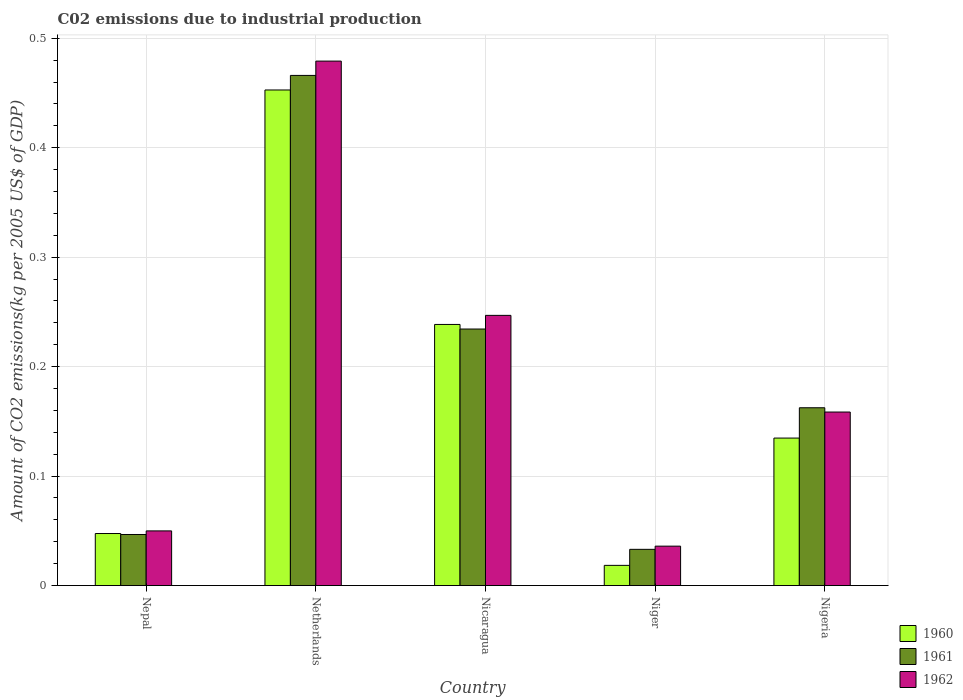How many groups of bars are there?
Make the answer very short. 5. What is the label of the 3rd group of bars from the left?
Provide a succinct answer. Nicaragua. In how many cases, is the number of bars for a given country not equal to the number of legend labels?
Offer a terse response. 0. What is the amount of CO2 emitted due to industrial production in 1960 in Nigeria?
Your answer should be compact. 0.13. Across all countries, what is the maximum amount of CO2 emitted due to industrial production in 1960?
Ensure brevity in your answer.  0.45. Across all countries, what is the minimum amount of CO2 emitted due to industrial production in 1960?
Ensure brevity in your answer.  0.02. In which country was the amount of CO2 emitted due to industrial production in 1962 maximum?
Ensure brevity in your answer.  Netherlands. In which country was the amount of CO2 emitted due to industrial production in 1960 minimum?
Offer a terse response. Niger. What is the total amount of CO2 emitted due to industrial production in 1961 in the graph?
Your answer should be compact. 0.94. What is the difference between the amount of CO2 emitted due to industrial production in 1961 in Netherlands and that in Nicaragua?
Ensure brevity in your answer.  0.23. What is the difference between the amount of CO2 emitted due to industrial production in 1961 in Netherlands and the amount of CO2 emitted due to industrial production in 1962 in Nicaragua?
Make the answer very short. 0.22. What is the average amount of CO2 emitted due to industrial production in 1960 per country?
Provide a succinct answer. 0.18. What is the difference between the amount of CO2 emitted due to industrial production of/in 1960 and amount of CO2 emitted due to industrial production of/in 1961 in Niger?
Keep it short and to the point. -0.01. In how many countries, is the amount of CO2 emitted due to industrial production in 1962 greater than 0.04 kg?
Provide a succinct answer. 4. What is the ratio of the amount of CO2 emitted due to industrial production in 1961 in Nicaragua to that in Nigeria?
Give a very brief answer. 1.44. Is the difference between the amount of CO2 emitted due to industrial production in 1960 in Nepal and Nicaragua greater than the difference between the amount of CO2 emitted due to industrial production in 1961 in Nepal and Nicaragua?
Give a very brief answer. No. What is the difference between the highest and the second highest amount of CO2 emitted due to industrial production in 1961?
Your answer should be compact. 0.3. What is the difference between the highest and the lowest amount of CO2 emitted due to industrial production in 1960?
Ensure brevity in your answer.  0.43. Is the sum of the amount of CO2 emitted due to industrial production in 1962 in Niger and Nigeria greater than the maximum amount of CO2 emitted due to industrial production in 1960 across all countries?
Your answer should be compact. No. What does the 1st bar from the right in Nigeria represents?
Offer a very short reply. 1962. Is it the case that in every country, the sum of the amount of CO2 emitted due to industrial production in 1960 and amount of CO2 emitted due to industrial production in 1962 is greater than the amount of CO2 emitted due to industrial production in 1961?
Your answer should be compact. Yes. How many bars are there?
Offer a terse response. 15. How many countries are there in the graph?
Your response must be concise. 5. How many legend labels are there?
Your response must be concise. 3. How are the legend labels stacked?
Ensure brevity in your answer.  Vertical. What is the title of the graph?
Offer a terse response. C02 emissions due to industrial production. What is the label or title of the Y-axis?
Your response must be concise. Amount of CO2 emissions(kg per 2005 US$ of GDP). What is the Amount of CO2 emissions(kg per 2005 US$ of GDP) in 1960 in Nepal?
Keep it short and to the point. 0.05. What is the Amount of CO2 emissions(kg per 2005 US$ of GDP) of 1961 in Nepal?
Provide a short and direct response. 0.05. What is the Amount of CO2 emissions(kg per 2005 US$ of GDP) of 1962 in Nepal?
Your response must be concise. 0.05. What is the Amount of CO2 emissions(kg per 2005 US$ of GDP) in 1960 in Netherlands?
Offer a terse response. 0.45. What is the Amount of CO2 emissions(kg per 2005 US$ of GDP) in 1961 in Netherlands?
Your answer should be very brief. 0.47. What is the Amount of CO2 emissions(kg per 2005 US$ of GDP) in 1962 in Netherlands?
Ensure brevity in your answer.  0.48. What is the Amount of CO2 emissions(kg per 2005 US$ of GDP) in 1960 in Nicaragua?
Provide a succinct answer. 0.24. What is the Amount of CO2 emissions(kg per 2005 US$ of GDP) of 1961 in Nicaragua?
Your answer should be compact. 0.23. What is the Amount of CO2 emissions(kg per 2005 US$ of GDP) of 1962 in Nicaragua?
Provide a succinct answer. 0.25. What is the Amount of CO2 emissions(kg per 2005 US$ of GDP) in 1960 in Niger?
Provide a succinct answer. 0.02. What is the Amount of CO2 emissions(kg per 2005 US$ of GDP) of 1961 in Niger?
Provide a succinct answer. 0.03. What is the Amount of CO2 emissions(kg per 2005 US$ of GDP) of 1962 in Niger?
Offer a terse response. 0.04. What is the Amount of CO2 emissions(kg per 2005 US$ of GDP) of 1960 in Nigeria?
Your response must be concise. 0.13. What is the Amount of CO2 emissions(kg per 2005 US$ of GDP) in 1961 in Nigeria?
Provide a succinct answer. 0.16. What is the Amount of CO2 emissions(kg per 2005 US$ of GDP) of 1962 in Nigeria?
Keep it short and to the point. 0.16. Across all countries, what is the maximum Amount of CO2 emissions(kg per 2005 US$ of GDP) in 1960?
Make the answer very short. 0.45. Across all countries, what is the maximum Amount of CO2 emissions(kg per 2005 US$ of GDP) of 1961?
Your answer should be compact. 0.47. Across all countries, what is the maximum Amount of CO2 emissions(kg per 2005 US$ of GDP) in 1962?
Offer a terse response. 0.48. Across all countries, what is the minimum Amount of CO2 emissions(kg per 2005 US$ of GDP) in 1960?
Keep it short and to the point. 0.02. Across all countries, what is the minimum Amount of CO2 emissions(kg per 2005 US$ of GDP) of 1961?
Offer a very short reply. 0.03. Across all countries, what is the minimum Amount of CO2 emissions(kg per 2005 US$ of GDP) in 1962?
Provide a succinct answer. 0.04. What is the total Amount of CO2 emissions(kg per 2005 US$ of GDP) in 1960 in the graph?
Provide a short and direct response. 0.89. What is the total Amount of CO2 emissions(kg per 2005 US$ of GDP) of 1961 in the graph?
Give a very brief answer. 0.94. What is the total Amount of CO2 emissions(kg per 2005 US$ of GDP) of 1962 in the graph?
Your answer should be very brief. 0.97. What is the difference between the Amount of CO2 emissions(kg per 2005 US$ of GDP) in 1960 in Nepal and that in Netherlands?
Provide a succinct answer. -0.41. What is the difference between the Amount of CO2 emissions(kg per 2005 US$ of GDP) of 1961 in Nepal and that in Netherlands?
Give a very brief answer. -0.42. What is the difference between the Amount of CO2 emissions(kg per 2005 US$ of GDP) of 1962 in Nepal and that in Netherlands?
Offer a terse response. -0.43. What is the difference between the Amount of CO2 emissions(kg per 2005 US$ of GDP) of 1960 in Nepal and that in Nicaragua?
Provide a short and direct response. -0.19. What is the difference between the Amount of CO2 emissions(kg per 2005 US$ of GDP) of 1961 in Nepal and that in Nicaragua?
Provide a short and direct response. -0.19. What is the difference between the Amount of CO2 emissions(kg per 2005 US$ of GDP) of 1962 in Nepal and that in Nicaragua?
Offer a very short reply. -0.2. What is the difference between the Amount of CO2 emissions(kg per 2005 US$ of GDP) in 1960 in Nepal and that in Niger?
Make the answer very short. 0.03. What is the difference between the Amount of CO2 emissions(kg per 2005 US$ of GDP) of 1961 in Nepal and that in Niger?
Make the answer very short. 0.01. What is the difference between the Amount of CO2 emissions(kg per 2005 US$ of GDP) in 1962 in Nepal and that in Niger?
Ensure brevity in your answer.  0.01. What is the difference between the Amount of CO2 emissions(kg per 2005 US$ of GDP) in 1960 in Nepal and that in Nigeria?
Offer a very short reply. -0.09. What is the difference between the Amount of CO2 emissions(kg per 2005 US$ of GDP) of 1961 in Nepal and that in Nigeria?
Ensure brevity in your answer.  -0.12. What is the difference between the Amount of CO2 emissions(kg per 2005 US$ of GDP) in 1962 in Nepal and that in Nigeria?
Keep it short and to the point. -0.11. What is the difference between the Amount of CO2 emissions(kg per 2005 US$ of GDP) of 1960 in Netherlands and that in Nicaragua?
Your answer should be compact. 0.21. What is the difference between the Amount of CO2 emissions(kg per 2005 US$ of GDP) in 1961 in Netherlands and that in Nicaragua?
Give a very brief answer. 0.23. What is the difference between the Amount of CO2 emissions(kg per 2005 US$ of GDP) of 1962 in Netherlands and that in Nicaragua?
Ensure brevity in your answer.  0.23. What is the difference between the Amount of CO2 emissions(kg per 2005 US$ of GDP) in 1960 in Netherlands and that in Niger?
Offer a terse response. 0.43. What is the difference between the Amount of CO2 emissions(kg per 2005 US$ of GDP) of 1961 in Netherlands and that in Niger?
Ensure brevity in your answer.  0.43. What is the difference between the Amount of CO2 emissions(kg per 2005 US$ of GDP) of 1962 in Netherlands and that in Niger?
Provide a succinct answer. 0.44. What is the difference between the Amount of CO2 emissions(kg per 2005 US$ of GDP) of 1960 in Netherlands and that in Nigeria?
Provide a short and direct response. 0.32. What is the difference between the Amount of CO2 emissions(kg per 2005 US$ of GDP) of 1961 in Netherlands and that in Nigeria?
Provide a succinct answer. 0.3. What is the difference between the Amount of CO2 emissions(kg per 2005 US$ of GDP) of 1962 in Netherlands and that in Nigeria?
Offer a terse response. 0.32. What is the difference between the Amount of CO2 emissions(kg per 2005 US$ of GDP) in 1960 in Nicaragua and that in Niger?
Keep it short and to the point. 0.22. What is the difference between the Amount of CO2 emissions(kg per 2005 US$ of GDP) in 1961 in Nicaragua and that in Niger?
Provide a succinct answer. 0.2. What is the difference between the Amount of CO2 emissions(kg per 2005 US$ of GDP) in 1962 in Nicaragua and that in Niger?
Keep it short and to the point. 0.21. What is the difference between the Amount of CO2 emissions(kg per 2005 US$ of GDP) of 1960 in Nicaragua and that in Nigeria?
Ensure brevity in your answer.  0.1. What is the difference between the Amount of CO2 emissions(kg per 2005 US$ of GDP) in 1961 in Nicaragua and that in Nigeria?
Your response must be concise. 0.07. What is the difference between the Amount of CO2 emissions(kg per 2005 US$ of GDP) in 1962 in Nicaragua and that in Nigeria?
Provide a short and direct response. 0.09. What is the difference between the Amount of CO2 emissions(kg per 2005 US$ of GDP) of 1960 in Niger and that in Nigeria?
Give a very brief answer. -0.12. What is the difference between the Amount of CO2 emissions(kg per 2005 US$ of GDP) of 1961 in Niger and that in Nigeria?
Ensure brevity in your answer.  -0.13. What is the difference between the Amount of CO2 emissions(kg per 2005 US$ of GDP) in 1962 in Niger and that in Nigeria?
Offer a terse response. -0.12. What is the difference between the Amount of CO2 emissions(kg per 2005 US$ of GDP) in 1960 in Nepal and the Amount of CO2 emissions(kg per 2005 US$ of GDP) in 1961 in Netherlands?
Your response must be concise. -0.42. What is the difference between the Amount of CO2 emissions(kg per 2005 US$ of GDP) in 1960 in Nepal and the Amount of CO2 emissions(kg per 2005 US$ of GDP) in 1962 in Netherlands?
Ensure brevity in your answer.  -0.43. What is the difference between the Amount of CO2 emissions(kg per 2005 US$ of GDP) of 1961 in Nepal and the Amount of CO2 emissions(kg per 2005 US$ of GDP) of 1962 in Netherlands?
Offer a very short reply. -0.43. What is the difference between the Amount of CO2 emissions(kg per 2005 US$ of GDP) in 1960 in Nepal and the Amount of CO2 emissions(kg per 2005 US$ of GDP) in 1961 in Nicaragua?
Ensure brevity in your answer.  -0.19. What is the difference between the Amount of CO2 emissions(kg per 2005 US$ of GDP) in 1960 in Nepal and the Amount of CO2 emissions(kg per 2005 US$ of GDP) in 1962 in Nicaragua?
Provide a succinct answer. -0.2. What is the difference between the Amount of CO2 emissions(kg per 2005 US$ of GDP) of 1961 in Nepal and the Amount of CO2 emissions(kg per 2005 US$ of GDP) of 1962 in Nicaragua?
Ensure brevity in your answer.  -0.2. What is the difference between the Amount of CO2 emissions(kg per 2005 US$ of GDP) of 1960 in Nepal and the Amount of CO2 emissions(kg per 2005 US$ of GDP) of 1961 in Niger?
Your answer should be compact. 0.01. What is the difference between the Amount of CO2 emissions(kg per 2005 US$ of GDP) of 1960 in Nepal and the Amount of CO2 emissions(kg per 2005 US$ of GDP) of 1962 in Niger?
Provide a succinct answer. 0.01. What is the difference between the Amount of CO2 emissions(kg per 2005 US$ of GDP) of 1961 in Nepal and the Amount of CO2 emissions(kg per 2005 US$ of GDP) of 1962 in Niger?
Offer a very short reply. 0.01. What is the difference between the Amount of CO2 emissions(kg per 2005 US$ of GDP) of 1960 in Nepal and the Amount of CO2 emissions(kg per 2005 US$ of GDP) of 1961 in Nigeria?
Offer a terse response. -0.11. What is the difference between the Amount of CO2 emissions(kg per 2005 US$ of GDP) in 1960 in Nepal and the Amount of CO2 emissions(kg per 2005 US$ of GDP) in 1962 in Nigeria?
Your response must be concise. -0.11. What is the difference between the Amount of CO2 emissions(kg per 2005 US$ of GDP) of 1961 in Nepal and the Amount of CO2 emissions(kg per 2005 US$ of GDP) of 1962 in Nigeria?
Your answer should be very brief. -0.11. What is the difference between the Amount of CO2 emissions(kg per 2005 US$ of GDP) of 1960 in Netherlands and the Amount of CO2 emissions(kg per 2005 US$ of GDP) of 1961 in Nicaragua?
Your response must be concise. 0.22. What is the difference between the Amount of CO2 emissions(kg per 2005 US$ of GDP) in 1960 in Netherlands and the Amount of CO2 emissions(kg per 2005 US$ of GDP) in 1962 in Nicaragua?
Ensure brevity in your answer.  0.21. What is the difference between the Amount of CO2 emissions(kg per 2005 US$ of GDP) in 1961 in Netherlands and the Amount of CO2 emissions(kg per 2005 US$ of GDP) in 1962 in Nicaragua?
Provide a succinct answer. 0.22. What is the difference between the Amount of CO2 emissions(kg per 2005 US$ of GDP) of 1960 in Netherlands and the Amount of CO2 emissions(kg per 2005 US$ of GDP) of 1961 in Niger?
Provide a short and direct response. 0.42. What is the difference between the Amount of CO2 emissions(kg per 2005 US$ of GDP) in 1960 in Netherlands and the Amount of CO2 emissions(kg per 2005 US$ of GDP) in 1962 in Niger?
Keep it short and to the point. 0.42. What is the difference between the Amount of CO2 emissions(kg per 2005 US$ of GDP) of 1961 in Netherlands and the Amount of CO2 emissions(kg per 2005 US$ of GDP) of 1962 in Niger?
Make the answer very short. 0.43. What is the difference between the Amount of CO2 emissions(kg per 2005 US$ of GDP) in 1960 in Netherlands and the Amount of CO2 emissions(kg per 2005 US$ of GDP) in 1961 in Nigeria?
Offer a terse response. 0.29. What is the difference between the Amount of CO2 emissions(kg per 2005 US$ of GDP) of 1960 in Netherlands and the Amount of CO2 emissions(kg per 2005 US$ of GDP) of 1962 in Nigeria?
Offer a very short reply. 0.29. What is the difference between the Amount of CO2 emissions(kg per 2005 US$ of GDP) in 1961 in Netherlands and the Amount of CO2 emissions(kg per 2005 US$ of GDP) in 1962 in Nigeria?
Provide a short and direct response. 0.31. What is the difference between the Amount of CO2 emissions(kg per 2005 US$ of GDP) of 1960 in Nicaragua and the Amount of CO2 emissions(kg per 2005 US$ of GDP) of 1961 in Niger?
Give a very brief answer. 0.21. What is the difference between the Amount of CO2 emissions(kg per 2005 US$ of GDP) of 1960 in Nicaragua and the Amount of CO2 emissions(kg per 2005 US$ of GDP) of 1962 in Niger?
Provide a succinct answer. 0.2. What is the difference between the Amount of CO2 emissions(kg per 2005 US$ of GDP) in 1961 in Nicaragua and the Amount of CO2 emissions(kg per 2005 US$ of GDP) in 1962 in Niger?
Offer a very short reply. 0.2. What is the difference between the Amount of CO2 emissions(kg per 2005 US$ of GDP) in 1960 in Nicaragua and the Amount of CO2 emissions(kg per 2005 US$ of GDP) in 1961 in Nigeria?
Make the answer very short. 0.08. What is the difference between the Amount of CO2 emissions(kg per 2005 US$ of GDP) in 1960 in Nicaragua and the Amount of CO2 emissions(kg per 2005 US$ of GDP) in 1962 in Nigeria?
Your answer should be very brief. 0.08. What is the difference between the Amount of CO2 emissions(kg per 2005 US$ of GDP) in 1961 in Nicaragua and the Amount of CO2 emissions(kg per 2005 US$ of GDP) in 1962 in Nigeria?
Provide a succinct answer. 0.08. What is the difference between the Amount of CO2 emissions(kg per 2005 US$ of GDP) in 1960 in Niger and the Amount of CO2 emissions(kg per 2005 US$ of GDP) in 1961 in Nigeria?
Offer a terse response. -0.14. What is the difference between the Amount of CO2 emissions(kg per 2005 US$ of GDP) in 1960 in Niger and the Amount of CO2 emissions(kg per 2005 US$ of GDP) in 1962 in Nigeria?
Make the answer very short. -0.14. What is the difference between the Amount of CO2 emissions(kg per 2005 US$ of GDP) in 1961 in Niger and the Amount of CO2 emissions(kg per 2005 US$ of GDP) in 1962 in Nigeria?
Your answer should be very brief. -0.13. What is the average Amount of CO2 emissions(kg per 2005 US$ of GDP) in 1960 per country?
Offer a very short reply. 0.18. What is the average Amount of CO2 emissions(kg per 2005 US$ of GDP) in 1961 per country?
Ensure brevity in your answer.  0.19. What is the average Amount of CO2 emissions(kg per 2005 US$ of GDP) in 1962 per country?
Ensure brevity in your answer.  0.19. What is the difference between the Amount of CO2 emissions(kg per 2005 US$ of GDP) in 1960 and Amount of CO2 emissions(kg per 2005 US$ of GDP) in 1961 in Nepal?
Your answer should be compact. 0. What is the difference between the Amount of CO2 emissions(kg per 2005 US$ of GDP) of 1960 and Amount of CO2 emissions(kg per 2005 US$ of GDP) of 1962 in Nepal?
Your answer should be compact. -0. What is the difference between the Amount of CO2 emissions(kg per 2005 US$ of GDP) of 1961 and Amount of CO2 emissions(kg per 2005 US$ of GDP) of 1962 in Nepal?
Offer a very short reply. -0. What is the difference between the Amount of CO2 emissions(kg per 2005 US$ of GDP) of 1960 and Amount of CO2 emissions(kg per 2005 US$ of GDP) of 1961 in Netherlands?
Your answer should be compact. -0.01. What is the difference between the Amount of CO2 emissions(kg per 2005 US$ of GDP) of 1960 and Amount of CO2 emissions(kg per 2005 US$ of GDP) of 1962 in Netherlands?
Provide a short and direct response. -0.03. What is the difference between the Amount of CO2 emissions(kg per 2005 US$ of GDP) in 1961 and Amount of CO2 emissions(kg per 2005 US$ of GDP) in 1962 in Netherlands?
Your answer should be very brief. -0.01. What is the difference between the Amount of CO2 emissions(kg per 2005 US$ of GDP) in 1960 and Amount of CO2 emissions(kg per 2005 US$ of GDP) in 1961 in Nicaragua?
Ensure brevity in your answer.  0. What is the difference between the Amount of CO2 emissions(kg per 2005 US$ of GDP) of 1960 and Amount of CO2 emissions(kg per 2005 US$ of GDP) of 1962 in Nicaragua?
Your answer should be compact. -0.01. What is the difference between the Amount of CO2 emissions(kg per 2005 US$ of GDP) of 1961 and Amount of CO2 emissions(kg per 2005 US$ of GDP) of 1962 in Nicaragua?
Offer a terse response. -0.01. What is the difference between the Amount of CO2 emissions(kg per 2005 US$ of GDP) of 1960 and Amount of CO2 emissions(kg per 2005 US$ of GDP) of 1961 in Niger?
Provide a short and direct response. -0.01. What is the difference between the Amount of CO2 emissions(kg per 2005 US$ of GDP) of 1960 and Amount of CO2 emissions(kg per 2005 US$ of GDP) of 1962 in Niger?
Your response must be concise. -0.02. What is the difference between the Amount of CO2 emissions(kg per 2005 US$ of GDP) in 1961 and Amount of CO2 emissions(kg per 2005 US$ of GDP) in 1962 in Niger?
Make the answer very short. -0. What is the difference between the Amount of CO2 emissions(kg per 2005 US$ of GDP) of 1960 and Amount of CO2 emissions(kg per 2005 US$ of GDP) of 1961 in Nigeria?
Make the answer very short. -0.03. What is the difference between the Amount of CO2 emissions(kg per 2005 US$ of GDP) in 1960 and Amount of CO2 emissions(kg per 2005 US$ of GDP) in 1962 in Nigeria?
Your response must be concise. -0.02. What is the difference between the Amount of CO2 emissions(kg per 2005 US$ of GDP) in 1961 and Amount of CO2 emissions(kg per 2005 US$ of GDP) in 1962 in Nigeria?
Make the answer very short. 0. What is the ratio of the Amount of CO2 emissions(kg per 2005 US$ of GDP) in 1960 in Nepal to that in Netherlands?
Provide a short and direct response. 0.1. What is the ratio of the Amount of CO2 emissions(kg per 2005 US$ of GDP) in 1961 in Nepal to that in Netherlands?
Give a very brief answer. 0.1. What is the ratio of the Amount of CO2 emissions(kg per 2005 US$ of GDP) in 1962 in Nepal to that in Netherlands?
Provide a short and direct response. 0.1. What is the ratio of the Amount of CO2 emissions(kg per 2005 US$ of GDP) in 1960 in Nepal to that in Nicaragua?
Your response must be concise. 0.2. What is the ratio of the Amount of CO2 emissions(kg per 2005 US$ of GDP) in 1961 in Nepal to that in Nicaragua?
Ensure brevity in your answer.  0.2. What is the ratio of the Amount of CO2 emissions(kg per 2005 US$ of GDP) in 1962 in Nepal to that in Nicaragua?
Ensure brevity in your answer.  0.2. What is the ratio of the Amount of CO2 emissions(kg per 2005 US$ of GDP) in 1960 in Nepal to that in Niger?
Your answer should be very brief. 2.58. What is the ratio of the Amount of CO2 emissions(kg per 2005 US$ of GDP) of 1961 in Nepal to that in Niger?
Offer a terse response. 1.41. What is the ratio of the Amount of CO2 emissions(kg per 2005 US$ of GDP) in 1962 in Nepal to that in Niger?
Provide a succinct answer. 1.39. What is the ratio of the Amount of CO2 emissions(kg per 2005 US$ of GDP) of 1960 in Nepal to that in Nigeria?
Your answer should be very brief. 0.35. What is the ratio of the Amount of CO2 emissions(kg per 2005 US$ of GDP) in 1961 in Nepal to that in Nigeria?
Your answer should be compact. 0.29. What is the ratio of the Amount of CO2 emissions(kg per 2005 US$ of GDP) of 1962 in Nepal to that in Nigeria?
Give a very brief answer. 0.32. What is the ratio of the Amount of CO2 emissions(kg per 2005 US$ of GDP) in 1960 in Netherlands to that in Nicaragua?
Provide a succinct answer. 1.9. What is the ratio of the Amount of CO2 emissions(kg per 2005 US$ of GDP) of 1961 in Netherlands to that in Nicaragua?
Provide a short and direct response. 1.99. What is the ratio of the Amount of CO2 emissions(kg per 2005 US$ of GDP) in 1962 in Netherlands to that in Nicaragua?
Provide a succinct answer. 1.94. What is the ratio of the Amount of CO2 emissions(kg per 2005 US$ of GDP) in 1960 in Netherlands to that in Niger?
Your response must be concise. 24.53. What is the ratio of the Amount of CO2 emissions(kg per 2005 US$ of GDP) of 1961 in Netherlands to that in Niger?
Ensure brevity in your answer.  14.08. What is the ratio of the Amount of CO2 emissions(kg per 2005 US$ of GDP) in 1962 in Netherlands to that in Niger?
Your response must be concise. 13.3. What is the ratio of the Amount of CO2 emissions(kg per 2005 US$ of GDP) in 1960 in Netherlands to that in Nigeria?
Give a very brief answer. 3.36. What is the ratio of the Amount of CO2 emissions(kg per 2005 US$ of GDP) in 1961 in Netherlands to that in Nigeria?
Your answer should be very brief. 2.87. What is the ratio of the Amount of CO2 emissions(kg per 2005 US$ of GDP) in 1962 in Netherlands to that in Nigeria?
Provide a short and direct response. 3.02. What is the ratio of the Amount of CO2 emissions(kg per 2005 US$ of GDP) in 1960 in Nicaragua to that in Niger?
Give a very brief answer. 12.93. What is the ratio of the Amount of CO2 emissions(kg per 2005 US$ of GDP) of 1961 in Nicaragua to that in Niger?
Provide a short and direct response. 7.08. What is the ratio of the Amount of CO2 emissions(kg per 2005 US$ of GDP) in 1962 in Nicaragua to that in Niger?
Make the answer very short. 6.85. What is the ratio of the Amount of CO2 emissions(kg per 2005 US$ of GDP) in 1960 in Nicaragua to that in Nigeria?
Your answer should be very brief. 1.77. What is the ratio of the Amount of CO2 emissions(kg per 2005 US$ of GDP) in 1961 in Nicaragua to that in Nigeria?
Your answer should be compact. 1.44. What is the ratio of the Amount of CO2 emissions(kg per 2005 US$ of GDP) of 1962 in Nicaragua to that in Nigeria?
Offer a terse response. 1.56. What is the ratio of the Amount of CO2 emissions(kg per 2005 US$ of GDP) of 1960 in Niger to that in Nigeria?
Offer a very short reply. 0.14. What is the ratio of the Amount of CO2 emissions(kg per 2005 US$ of GDP) of 1961 in Niger to that in Nigeria?
Your response must be concise. 0.2. What is the ratio of the Amount of CO2 emissions(kg per 2005 US$ of GDP) of 1962 in Niger to that in Nigeria?
Your answer should be compact. 0.23. What is the difference between the highest and the second highest Amount of CO2 emissions(kg per 2005 US$ of GDP) of 1960?
Provide a short and direct response. 0.21. What is the difference between the highest and the second highest Amount of CO2 emissions(kg per 2005 US$ of GDP) of 1961?
Provide a short and direct response. 0.23. What is the difference between the highest and the second highest Amount of CO2 emissions(kg per 2005 US$ of GDP) of 1962?
Provide a short and direct response. 0.23. What is the difference between the highest and the lowest Amount of CO2 emissions(kg per 2005 US$ of GDP) in 1960?
Your answer should be very brief. 0.43. What is the difference between the highest and the lowest Amount of CO2 emissions(kg per 2005 US$ of GDP) of 1961?
Provide a short and direct response. 0.43. What is the difference between the highest and the lowest Amount of CO2 emissions(kg per 2005 US$ of GDP) of 1962?
Offer a terse response. 0.44. 